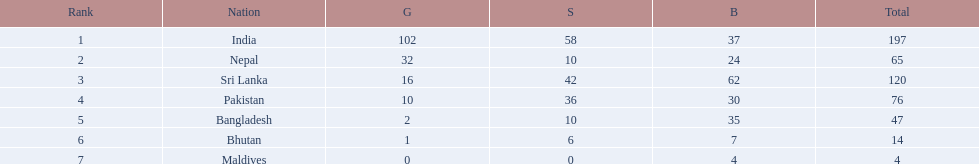What are the totals of medals one in each country? 197, 65, 120, 76, 47, 14, 4. Which of these totals are less than 10? 4. Who won this number of medals? Maldives. 